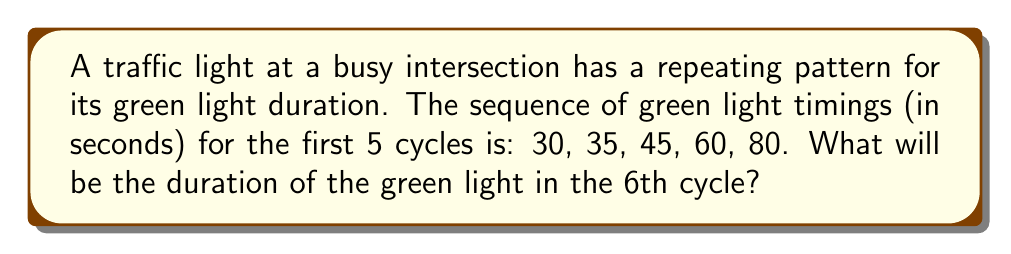Can you solve this math problem? To solve this problem, we need to identify the pattern in the sequence:

1. First, let's calculate the differences between consecutive terms:
   $35 - 30 = 5$
   $45 - 35 = 10$
   $60 - 45 = 15$
   $80 - 60 = 20$

2. We can observe that the differences are increasing by 5 each time:
   $5, 10, 15, 20$

3. This suggests that the sequence follows a quadratic pattern.

4. To confirm this, let's calculate the second differences:
   $10 - 5 = 5$
   $15 - 10 = 5$
   $20 - 15 = 5$

5. The constant second difference of 5 confirms that this is indeed a quadratic sequence.

6. The general form of a quadratic sequence is:
   $a_n = an^2 + bn + c$, where $n$ is the term number.

7. Using the first three terms, we can set up a system of equations:
   $30 = a(1)^2 + b(1) + c$
   $35 = a(2)^2 + b(2) + c$
   $45 = a(3)^2 + b(3) + c$

8. Solving this system (which is beyond the scope of this explanation), we get:
   $a = 2.5$, $b = 2.5$, $c = 25$

9. Therefore, the general term of the sequence is:
   $a_n = 2.5n^2 + 2.5n + 25$

10. To find the 6th term, we substitute $n = 6$:
    $a_6 = 2.5(6)^2 + 2.5(6) + 25 = 2.5(36) + 15 + 25 = 90 + 15 + 25 = 130$

Thus, the duration of the green light in the 6th cycle will be 130 seconds.
Answer: 130 seconds 